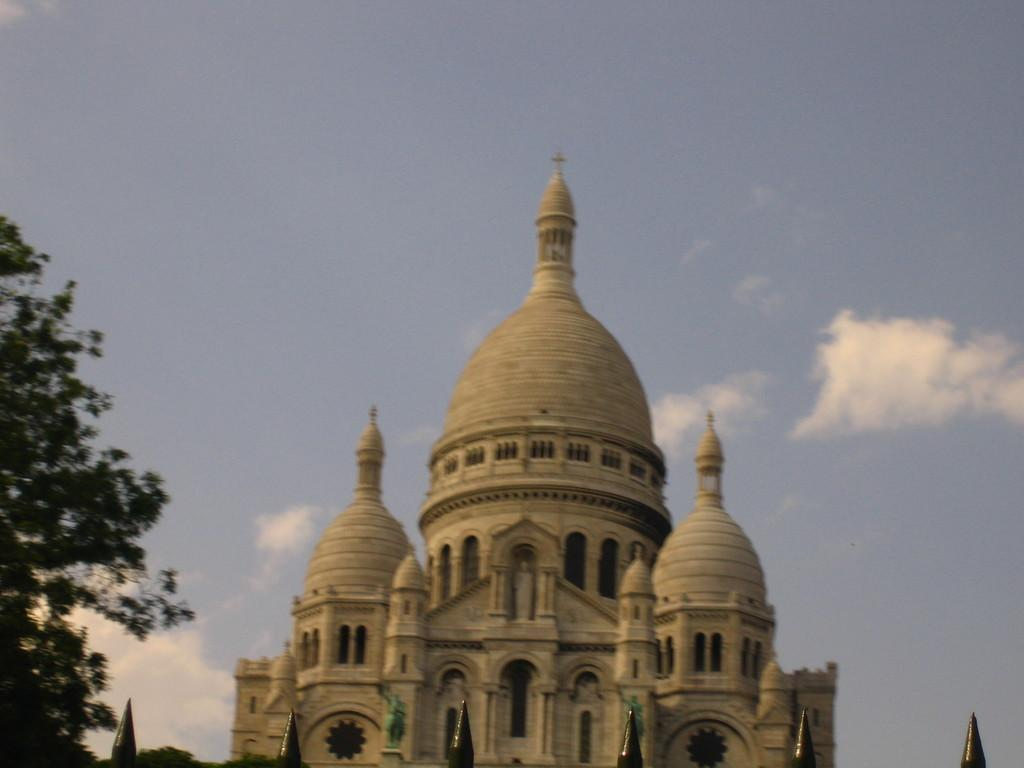What type of structure is visible in the image? There is a building in the image. Where is the tree located in relation to the building? The tree is on the left side of the image. What can be seen in the background of the image? The sky is visible behind the building. What is present at the bottom of the image? There are objects at the bottom of the image. How many babies are playing with a hammer in the image? There are no babies or hammers present in the image. Are the sisters in the image holding hands? There is no mention of sisters in the image, so we cannot determine if they are holding hands. 